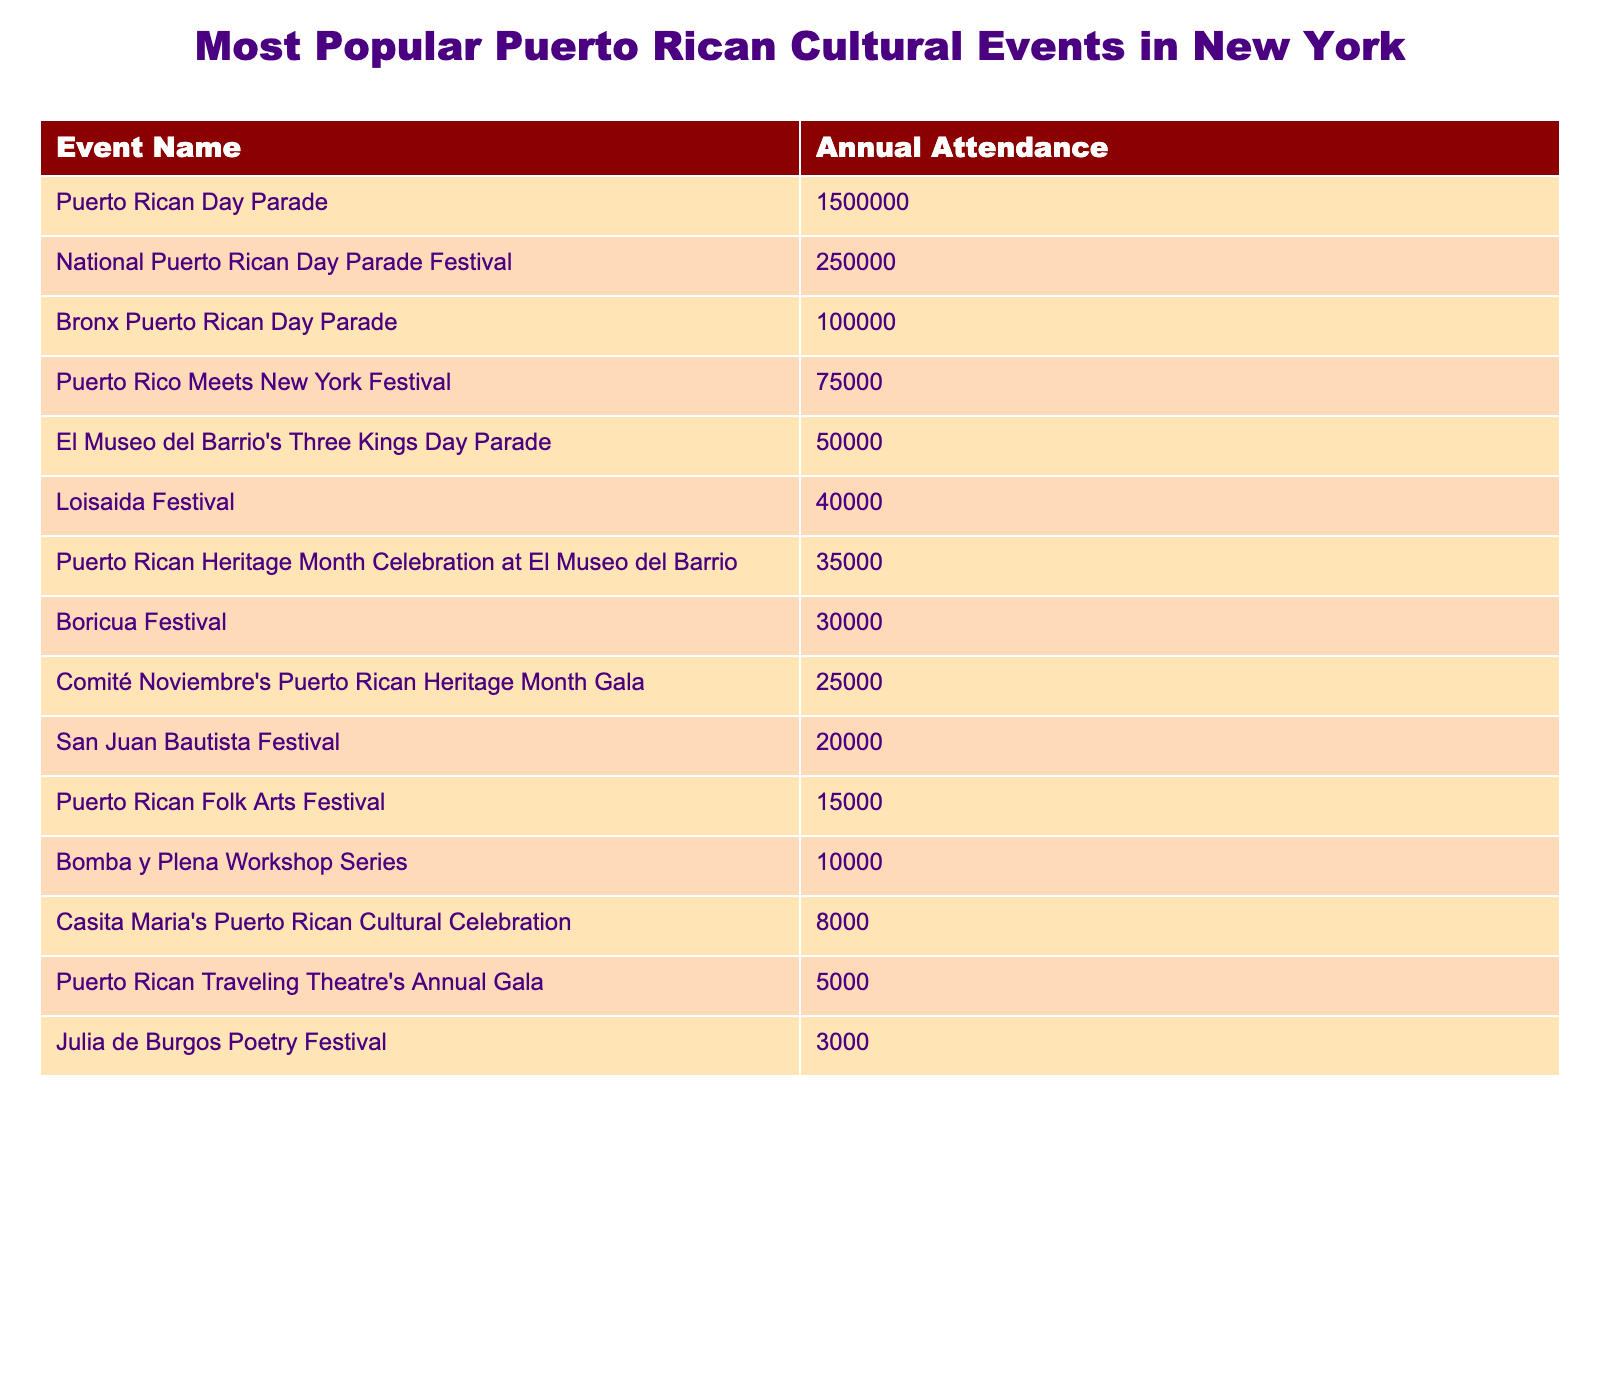What is the annual attendance of the Puerto Rican Day Parade? The table clearly lists the Puerto Rican Day Parade's annual attendance as 1,500,000.
Answer: 1,500,000 Which event has the least annual attendance? By scanning the attendance figures, the Julia de Burgos Poetry Festival has the lowest attendance at 3,000.
Answer: 3,000 What is the total annual attendance for the top three events? The top three events are the Puerto Rican Day Parade (1,500,000), National Puerto Rican Day Parade Festival (250,000), and Bronx Puerto Rican Day Parade (100,000). Adding these gives 1,500,000 + 250,000 + 100,000 = 1,850,000.
Answer: 1,850,000 Is the Loisaida Festival attendance greater than the Bomba y Plena Workshop Series? The Loisaida Festival has an attendance of 40,000 whereas the Bomba y Plena Workshop Series has 10,000. Since 40,000 is greater than 10,000, the statement is true.
Answer: Yes How many events have an attendance of over 50,000? The events with attendance over 50,000 are the Puerto Rican Day Parade (1,500,000), National Puerto Rican Day Parade Festival (250,000), and Bronx Puerto Rican Day Parade (100,000), totaling three events.
Answer: 3 What is the difference in attendance between the Puerto Rico Meets New York Festival and the Casita Maria's Puerto Rican Cultural Celebration? The Puerto Rico Meets New York Festival has 75,000 attendees, while Casita Maria's Puerto Rican Cultural Celebration has 8,000. The difference is 75,000 - 8,000 = 67,000.
Answer: 67,000 What percentage of the total attendance is represented by the San Juan Bautista Festival? To find the percentage of total attendance represented by the San Juan Bautista Festival, first calculate the total attendance: 1,500,000 + 250,000 + 100,000 + 75,000 + 50,000 + 40,000 + 35,000 + 30,000 + 25,000 + 20,000 + 15,000 + 10,000 + 8,000 + 5,000 + 3,000 = 2,083,000. The San Juan Bautista Festival has 20,000 attendees, so the percentage is (20,000 / 2,083,000) * 100 = approximately 0.96%.
Answer: 0.96% If you combine the attendance of the El Museo del Barrio's Three Kings Day Parade and the Puerto Rican Folk Arts Festival, how many attendees would you have? El Museo del Barrio's Three Kings Day Parade has 50,000 attendees and the Puerto Rican Folk Arts Festival has 15,000. Adding these gives 50,000 + 15,000 = 65,000 attendees in total.
Answer: 65,000 Are there more events listed with attendance below 30,000 or above 70,000? The events below 30,000 include the Boricua Festival (30,000), Comité Noviembre's Puerto Rican Heritage Month Gala (25,000), San Juan Bautista Festival (20,000), Puerto Rican Folk Arts Festival (15,000), Bomba y Plena Workshop Series (10,000), Casita Maria's Puerto Rican Cultural Celebration (8,000), Puerto Rican Traveling Theatre's Annual Gala (5,000), and Julia de Burgos Poetry Festival (3,000), totaling eight events. The only event above 70,000 is the Puerto Rican Day Parade. Hence, there are more events listed below 30,000.
Answer: Below 30,000 What are the two most attended events combined? The two most attended events are the Puerto Rican Day Parade (1,500,000) and the National Puerto Rican Day Parade Festival (250,000). Combined, they have 1,500,000 + 250,000 = 1,750,000 attendees.
Answer: 1,750,000 